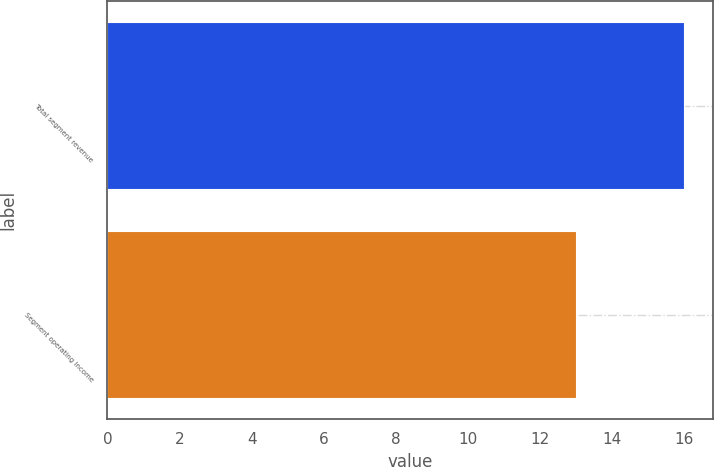Convert chart. <chart><loc_0><loc_0><loc_500><loc_500><bar_chart><fcel>Total segment revenue<fcel>Segment operating income<nl><fcel>16<fcel>13<nl></chart> 